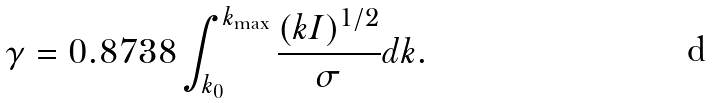<formula> <loc_0><loc_0><loc_500><loc_500>\gamma = 0 . 8 7 3 8 \int _ { k _ { 0 } } ^ { k _ { \max } } \frac { ( k I ) ^ { 1 / 2 } } { \sigma } d k .</formula> 